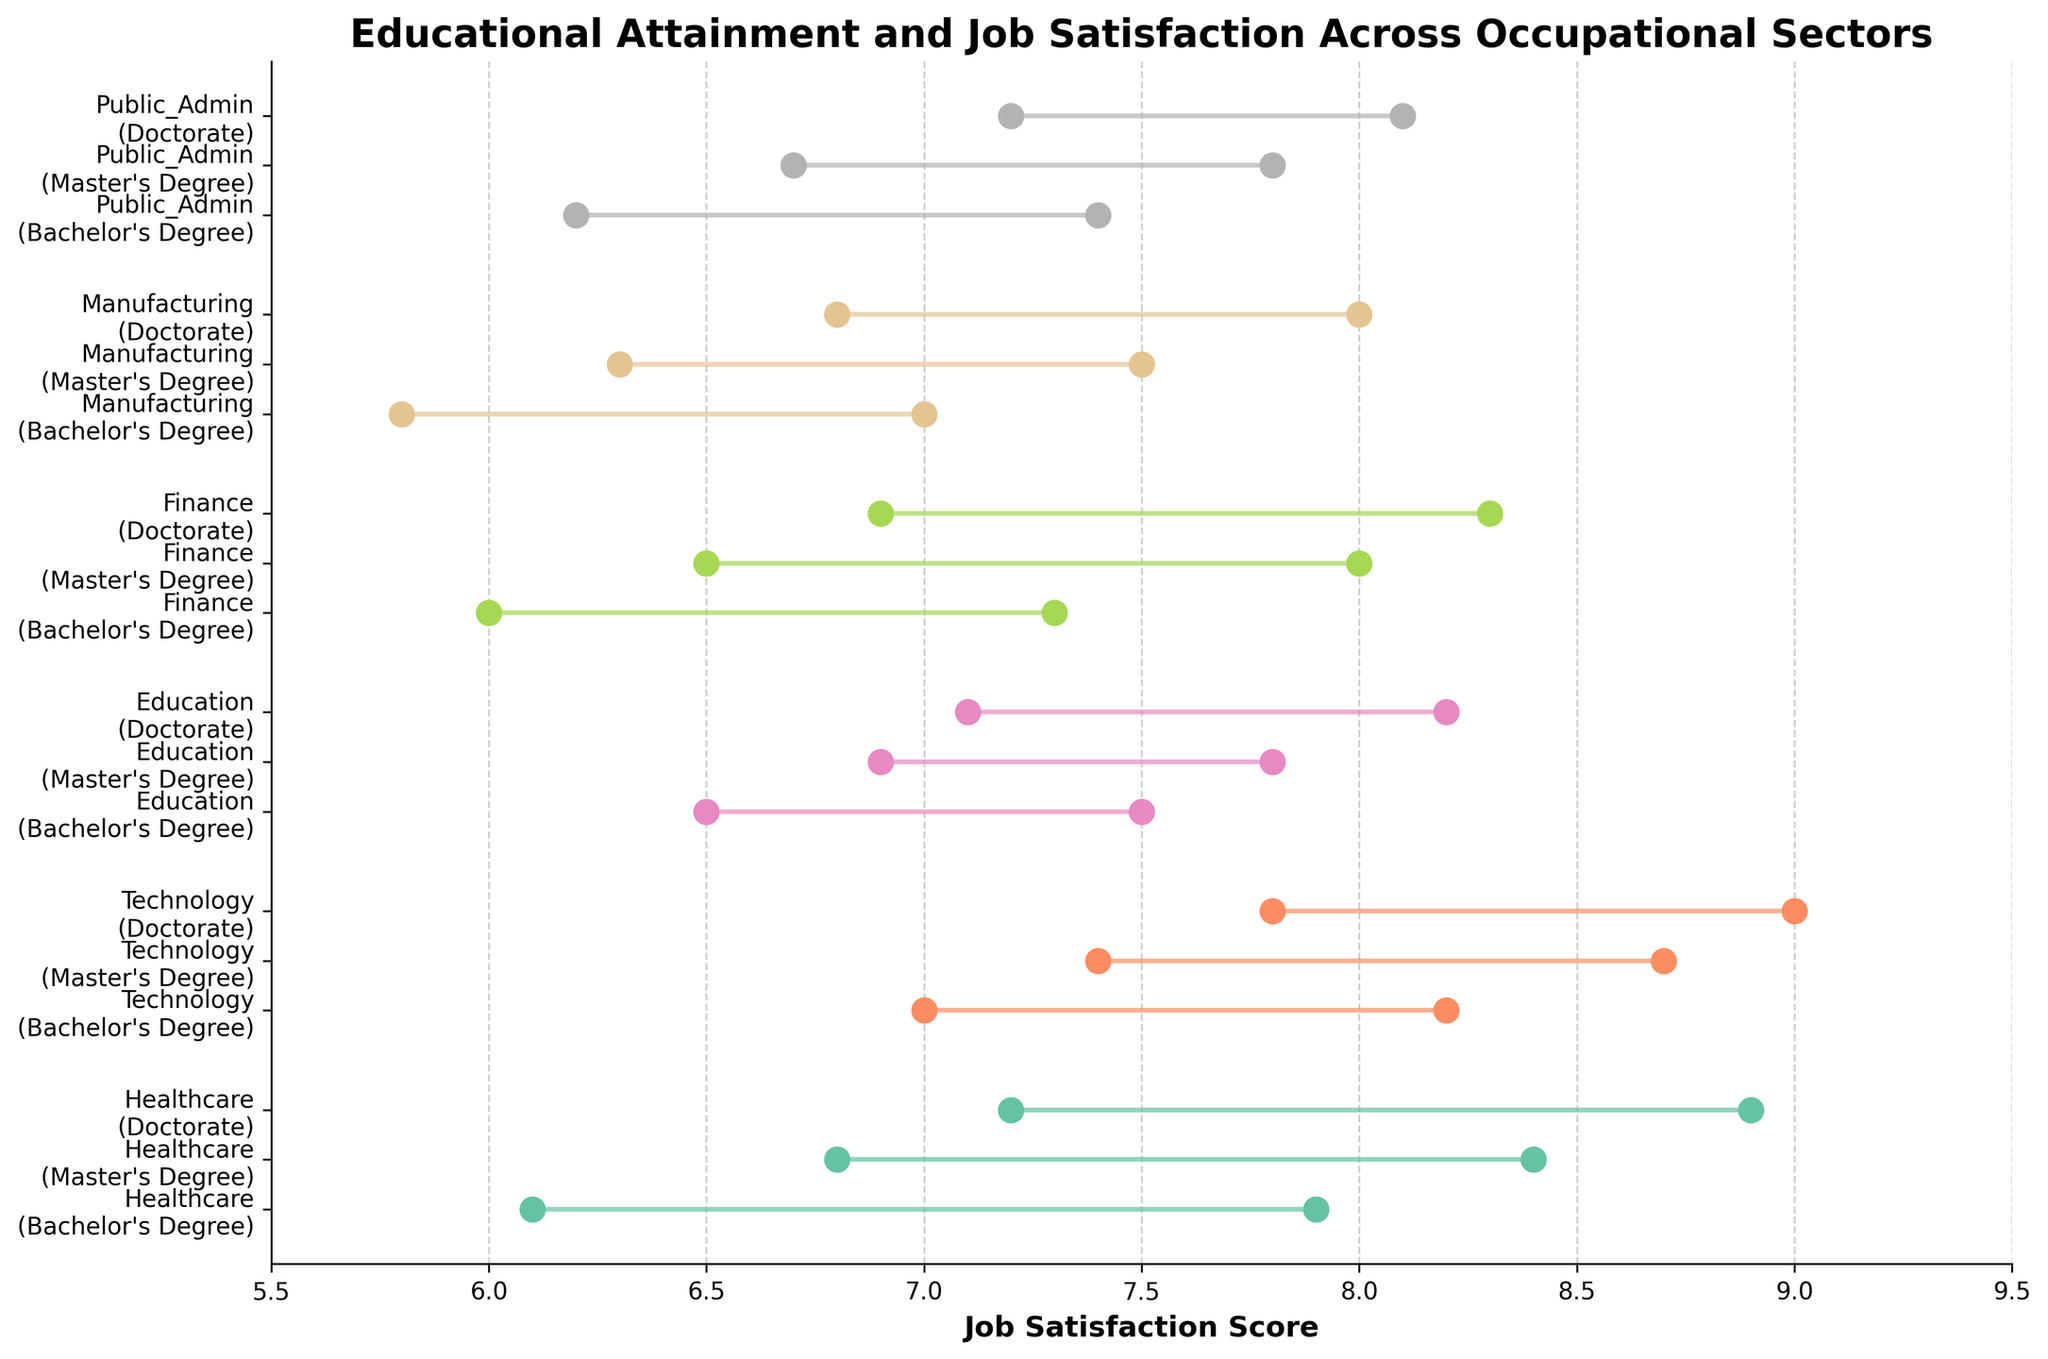What is the minimum job satisfaction score for individuals with a Bachelor's Degree in Finance? Look at the range of the job satisfaction scores for individuals with a Bachelor's Degree in Finance, focusing on the minimum value.
Answer: 6.0 Which occupational sector has the highest maximum job satisfaction score? Compare the maximum job satisfaction scores across all occupational sectors and find the highest value.
Answer: Technology What is the range of job satisfaction scores for individuals with a Master's Degree in Healthcare? Find the difference between the maximum and minimum job satisfaction scores for individuals with a Master's Degree in Healthcare.
Answer: 1.6 Compare the job satisfaction range of individuals with a Doctorate in Education to those in Finance. Which is larger? Calculate the job satisfaction score range for Doctorate holders in both Education and Finance by subtracting the minimum score from the maximum score in each case, and then compare the two ranges.
Answer: Education What is the visible trend in job satisfaction scores as the education level increases within the Technology sector? Observe the job satisfaction scores across different education levels within the Technology sector to identify any trends.
Answer: Increasing Which education level in the Public Administration sector has the narrowest range of job satisfaction scores? Compare the ranges of job satisfaction scores for different education levels in the Public Administration sector to identify the smallest range.
Answer: Bachelor's Degree What is the average minimum job satisfaction score across all sectors for individuals with a Bachelor's Degree? Add the minimum job satisfaction scores for individuals with a Bachelor's Degree across all sectors and divide by the number of sectors.
Answer: 6.267 How does the job satisfaction range for individuals with a Master's Degree in Manufacturing compare to those in Healthcare? Calculate the range for both, Manufacturing (7.5 - 6.3) = 1.2 and Healthcare (8.4 - 6.8) = 1.6, then compare the values.
Answer: Healthcare is larger Which sector shows the widest range in job satisfaction scores regardless of education level? Observe and compare the widest ranges (maximum - minimum scores) of job satisfaction in each sector to identify the sector with the widest range.
Answer: Healthcare What is the difference between the maximum job satisfaction scores for individuals with Doctorates in Technology and Finance? Subtract the maximum job satisfaction score of Finance (8.3) from that of Technology (9.0).
Answer: 0.7 